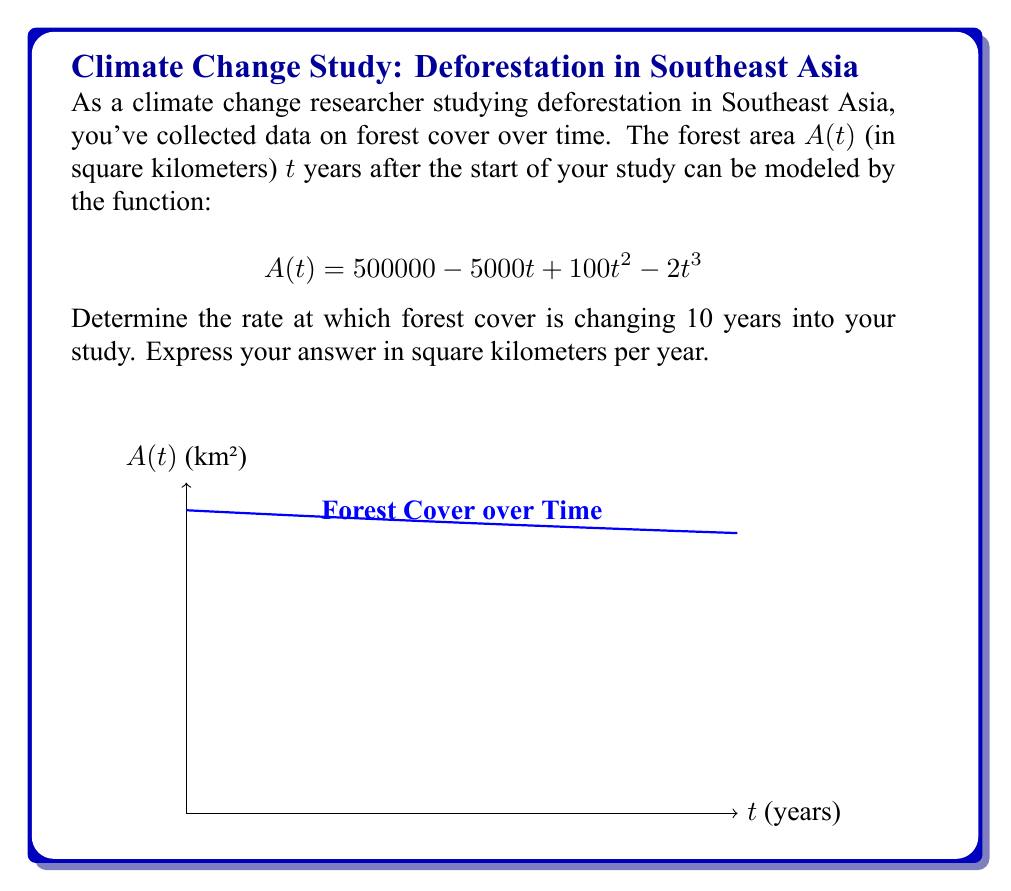Give your solution to this math problem. To solve this problem, we need to follow these steps:

1) The rate of change of forest cover is given by the derivative of $A(t)$ with respect to $t$.

2) Let's find $\frac{dA}{dt}$ using the power rule:

   $$\frac{dA}{dt} = -5000 + 200t - 6t^2$$

3) We need to evaluate this derivative at $t = 10$ years:

   $$\frac{dA}{dt}\bigg|_{t=10} = -5000 + 200(10) - 6(10)^2$$

4) Let's calculate this step by step:
   
   $$\begin{align}
   \frac{dA}{dt}\bigg|_{t=10} &= -5000 + 2000 - 6(100) \\
   &= -5000 + 2000 - 600 \\
   &= -3600
   \end{align}$$

5) The negative value indicates that the forest cover is decreasing.

Therefore, 10 years into the study, the forest cover is decreasing at a rate of 3600 square kilometers per year.
Answer: $-3600$ km²/year 